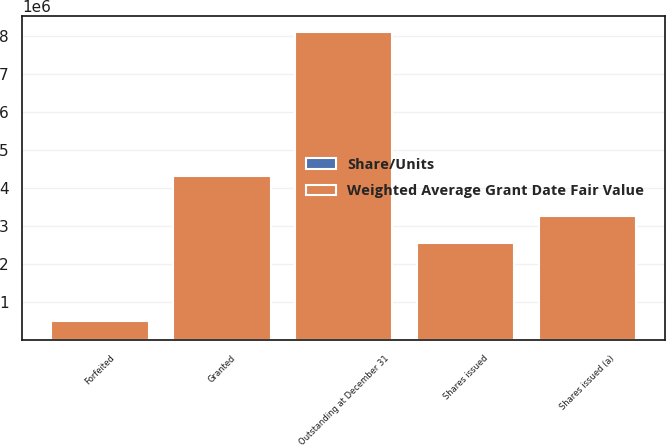Convert chart. <chart><loc_0><loc_0><loc_500><loc_500><stacked_bar_chart><ecel><fcel>Outstanding at December 31<fcel>Granted<fcel>Shares issued<fcel>Forfeited<fcel>Shares issued (a)<nl><fcel>Weighted Average Grant Date Fair Value<fcel>8.11749e+06<fcel>4.31438e+06<fcel>2.56597e+06<fcel>500940<fcel>3.26276e+06<nl><fcel>Share/Units<fcel>31.2<fcel>28.04<fcel>32.43<fcel>25.07<fcel>32.48<nl></chart> 